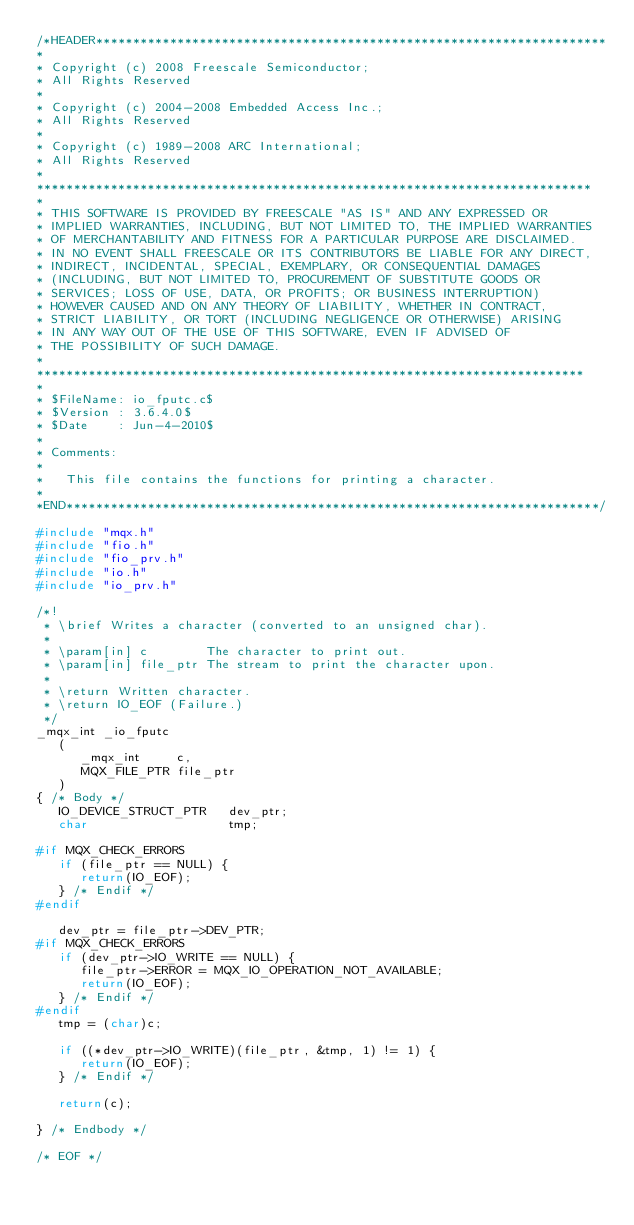Convert code to text. <code><loc_0><loc_0><loc_500><loc_500><_C_>/*HEADER*********************************************************************
* 
* Copyright (c) 2008 Freescale Semiconductor;
* All Rights Reserved
*
* Copyright (c) 2004-2008 Embedded Access Inc.;
* All Rights Reserved
*
* Copyright (c) 1989-2008 ARC International;
* All Rights Reserved
*
*************************************************************************** 
*
* THIS SOFTWARE IS PROVIDED BY FREESCALE "AS IS" AND ANY EXPRESSED OR 
* IMPLIED WARRANTIES, INCLUDING, BUT NOT LIMITED TO, THE IMPLIED WARRANTIES 
* OF MERCHANTABILITY AND FITNESS FOR A PARTICULAR PURPOSE ARE DISCLAIMED.  
* IN NO EVENT SHALL FREESCALE OR ITS CONTRIBUTORS BE LIABLE FOR ANY DIRECT, 
* INDIRECT, INCIDENTAL, SPECIAL, EXEMPLARY, OR CONSEQUENTIAL DAMAGES 
* (INCLUDING, BUT NOT LIMITED TO, PROCUREMENT OF SUBSTITUTE GOODS OR 
* SERVICES; LOSS OF USE, DATA, OR PROFITS; OR BUSINESS INTERRUPTION) 
* HOWEVER CAUSED AND ON ANY THEORY OF LIABILITY, WHETHER IN CONTRACT, 
* STRICT LIABILITY, OR TORT (INCLUDING NEGLIGENCE OR OTHERWISE) ARISING 
* IN ANY WAY OUT OF THE USE OF THIS SOFTWARE, EVEN IF ADVISED OF 
* THE POSSIBILITY OF SUCH DAMAGE.
*
**************************************************************************
*
* $FileName: io_fputc.c$
* $Version : 3.6.4.0$
* $Date    : Jun-4-2010$
*
* Comments:
*
*   This file contains the functions for printing a character.
*
*END************************************************************************/

#include "mqx.h"
#include "fio.h"
#include "fio_prv.h"
#include "io.h"
#include "io_prv.h"

/*!
 * \brief Writes a character (converted to an unsigned char).
 * 
 * \param[in] c        The character to print out.
 * \param[in] file_ptr The stream to print the character upon.
 * 
 * \return Written character.
 * \return IO_EOF (Failure.) 
 */ 
_mqx_int _io_fputc
   (
      _mqx_int     c,
      MQX_FILE_PTR file_ptr
   )
{ /* Body */
   IO_DEVICE_STRUCT_PTR   dev_ptr;
   char                   tmp;

#if MQX_CHECK_ERRORS
   if (file_ptr == NULL) {
      return(IO_EOF);
   } /* Endif */
#endif

   dev_ptr = file_ptr->DEV_PTR;
#if MQX_CHECK_ERRORS
   if (dev_ptr->IO_WRITE == NULL) {
      file_ptr->ERROR = MQX_IO_OPERATION_NOT_AVAILABLE;
      return(IO_EOF);
   } /* Endif */
#endif
   tmp = (char)c;

   if ((*dev_ptr->IO_WRITE)(file_ptr, &tmp, 1) != 1) {
      return(IO_EOF);
   } /* Endif */

   return(c);

} /* Endbody */

/* EOF */
</code> 